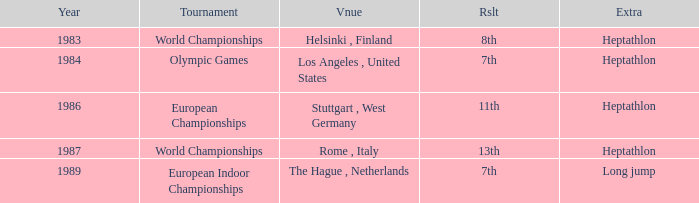Where was the 1984 Olympics hosted? Olympic Games. 